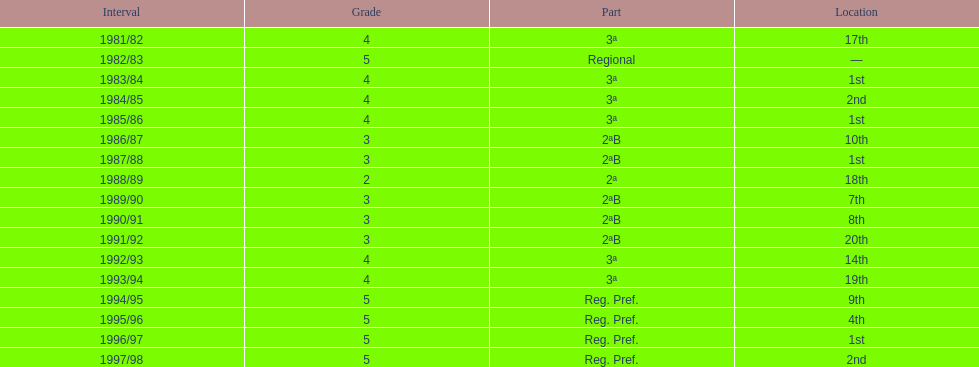What was the duration of their stay in tier 3 in years? 5. 